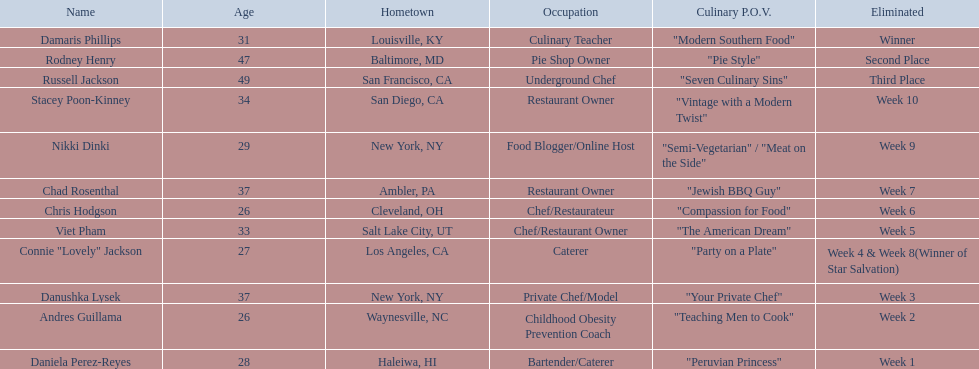Besides the top three winners, who were the eliminated contestants? Stacey Poon-Kinney, Nikki Dinki, Chad Rosenthal, Chris Hodgson, Viet Pham, Connie "Lovely" Jackson, Danushka Lysek, Andres Guillama, Daniela Perez-Reyes. Who were the last five contestants to be eliminated before the winner, second, and third place winners were declared? Stacey Poon-Kinney, Nikki Dinki, Chad Rosenthal, Chris Hodgson, Viet Pham. Among these five, was it nikki dinki or viet pham who was eliminated first? Viet Pham. 